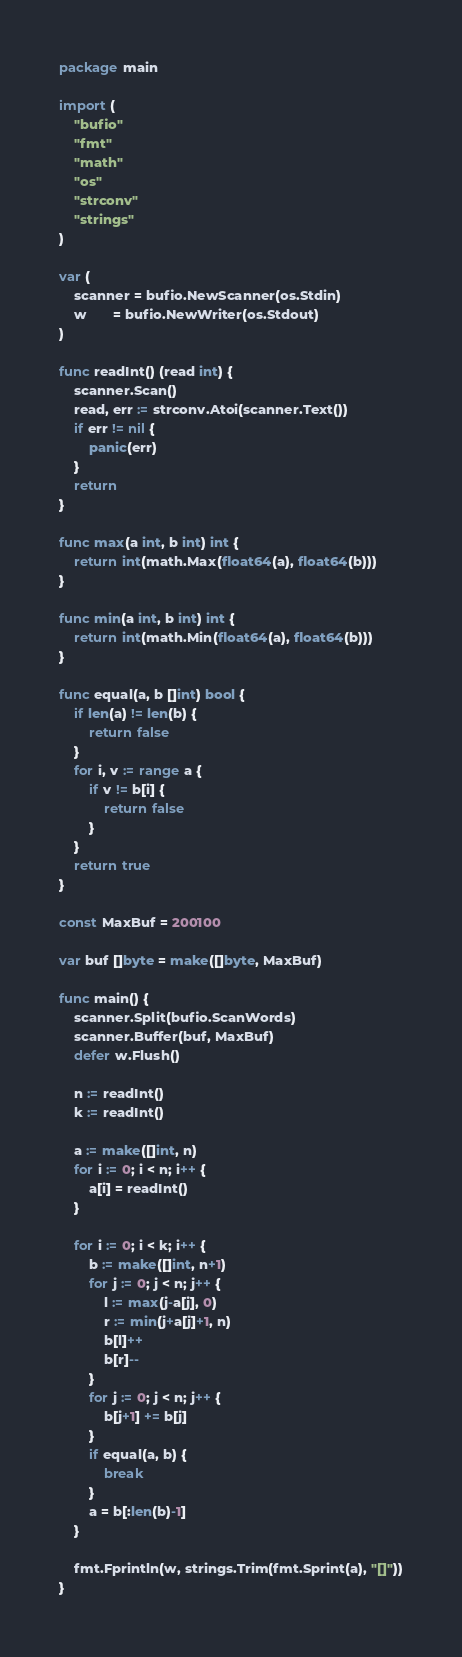<code> <loc_0><loc_0><loc_500><loc_500><_Go_>package main

import (
	"bufio"
	"fmt"
	"math"
	"os"
	"strconv"
	"strings"
)

var (
	scanner = bufio.NewScanner(os.Stdin)
	w       = bufio.NewWriter(os.Stdout)
)

func readInt() (read int) {
	scanner.Scan()
	read, err := strconv.Atoi(scanner.Text())
	if err != nil {
		panic(err)
	}
	return
}

func max(a int, b int) int {
	return int(math.Max(float64(a), float64(b)))
}

func min(a int, b int) int {
	return int(math.Min(float64(a), float64(b)))
}

func equal(a, b []int) bool {
	if len(a) != len(b) {
		return false
	}
	for i, v := range a {
		if v != b[i] {
			return false
		}
	}
	return true
}

const MaxBuf = 200100

var buf []byte = make([]byte, MaxBuf)

func main() {
	scanner.Split(bufio.ScanWords)
	scanner.Buffer(buf, MaxBuf)
	defer w.Flush()

	n := readInt()
	k := readInt()

	a := make([]int, n)
	for i := 0; i < n; i++ {
		a[i] = readInt()
	}

	for i := 0; i < k; i++ {
		b := make([]int, n+1)
		for j := 0; j < n; j++ {
			l := max(j-a[j], 0)
			r := min(j+a[j]+1, n)
			b[l]++
			b[r]--
		}
		for j := 0; j < n; j++ {
			b[j+1] += b[j]
		}
		if equal(a, b) {
			break
		}
		a = b[:len(b)-1]
	}

	fmt.Fprintln(w, strings.Trim(fmt.Sprint(a), "[]"))
}
</code> 